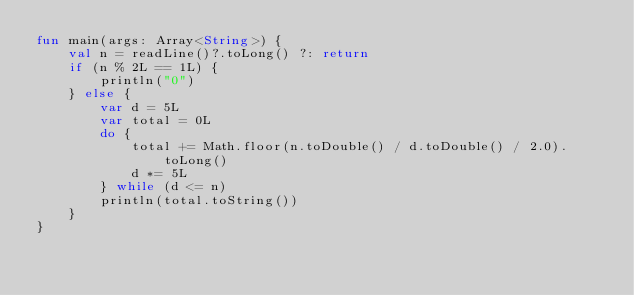Convert code to text. <code><loc_0><loc_0><loc_500><loc_500><_Kotlin_>fun main(args: Array<String>) {
    val n = readLine()?.toLong() ?: return
    if (n % 2L == 1L) {
        println("0")
    } else {
        var d = 5L
        var total = 0L
        do {
            total += Math.floor(n.toDouble() / d.toDouble() / 2.0).toLong()
            d *= 5L
        } while (d <= n)
        println(total.toString())
    }
}
</code> 